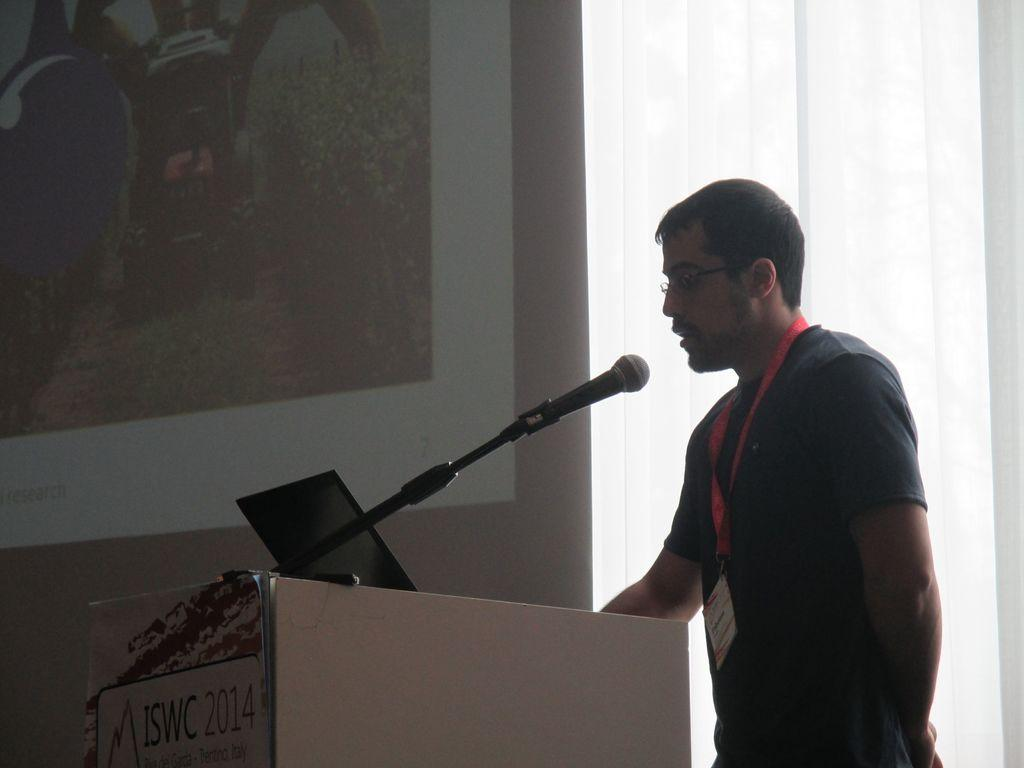What is the person in the image doing? The person is talking into a microphone. What object is the person using to amplify their voice? The person is using a microphone. What structure can be seen in the image? There is a podium in the image. What is visible in the background of the image? There is a wall in the background of the image. What type of meal is being served on the crate in the image? There is no crate or meal present in the image. 